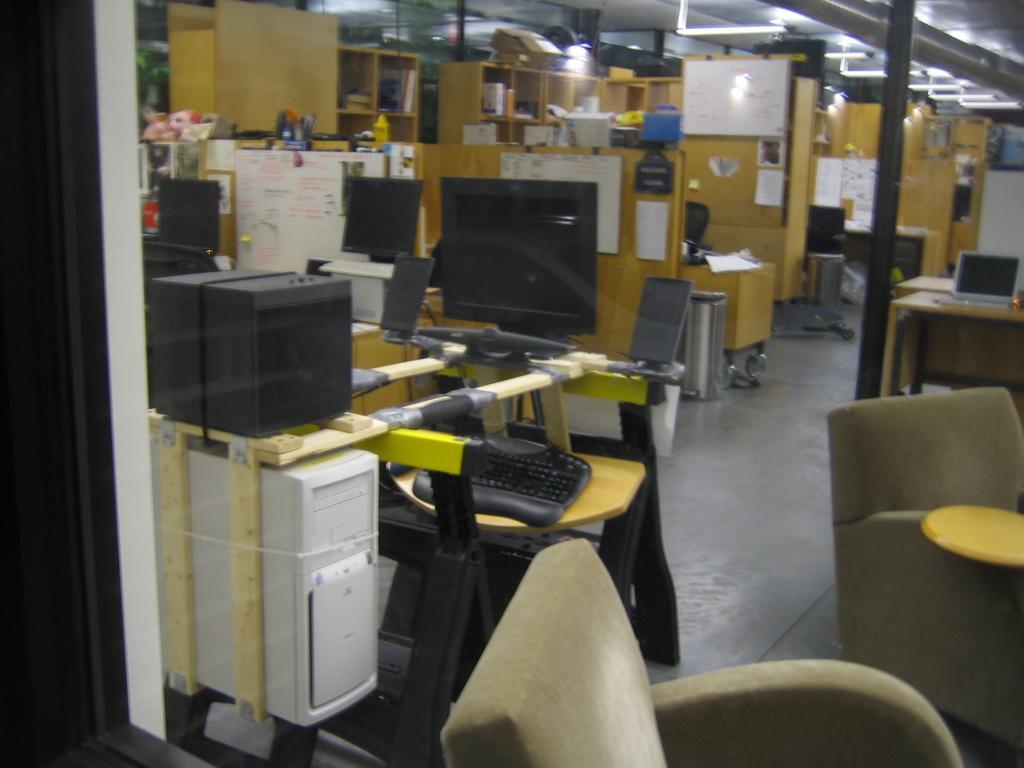Can you describe this image briefly? In this picture we can see a few computers, chairs, papers, toys, books and pens in the stand. We can see some lights on top. There are some objects in the shelves. 